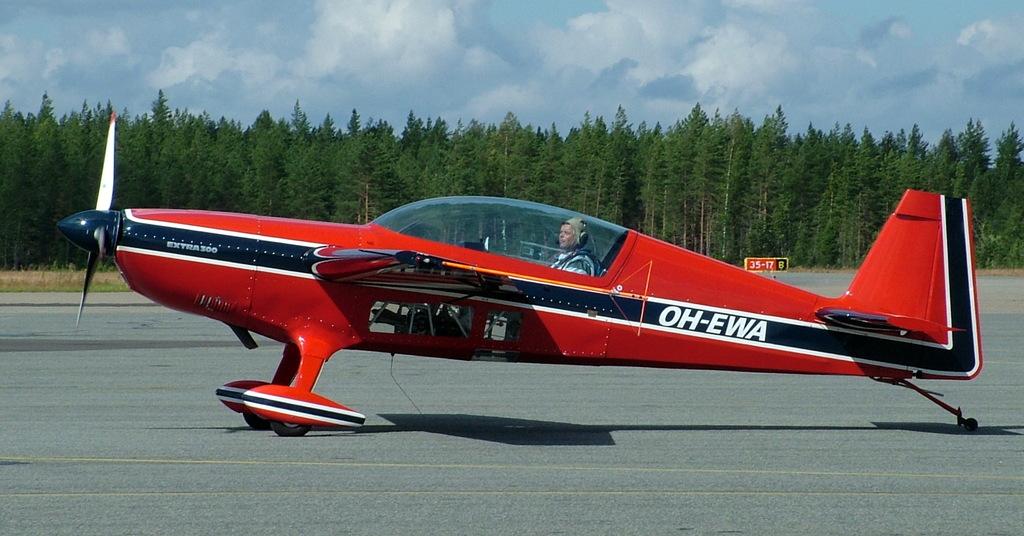What is the call number of the plane?
Give a very brief answer. Oh-ewa. 